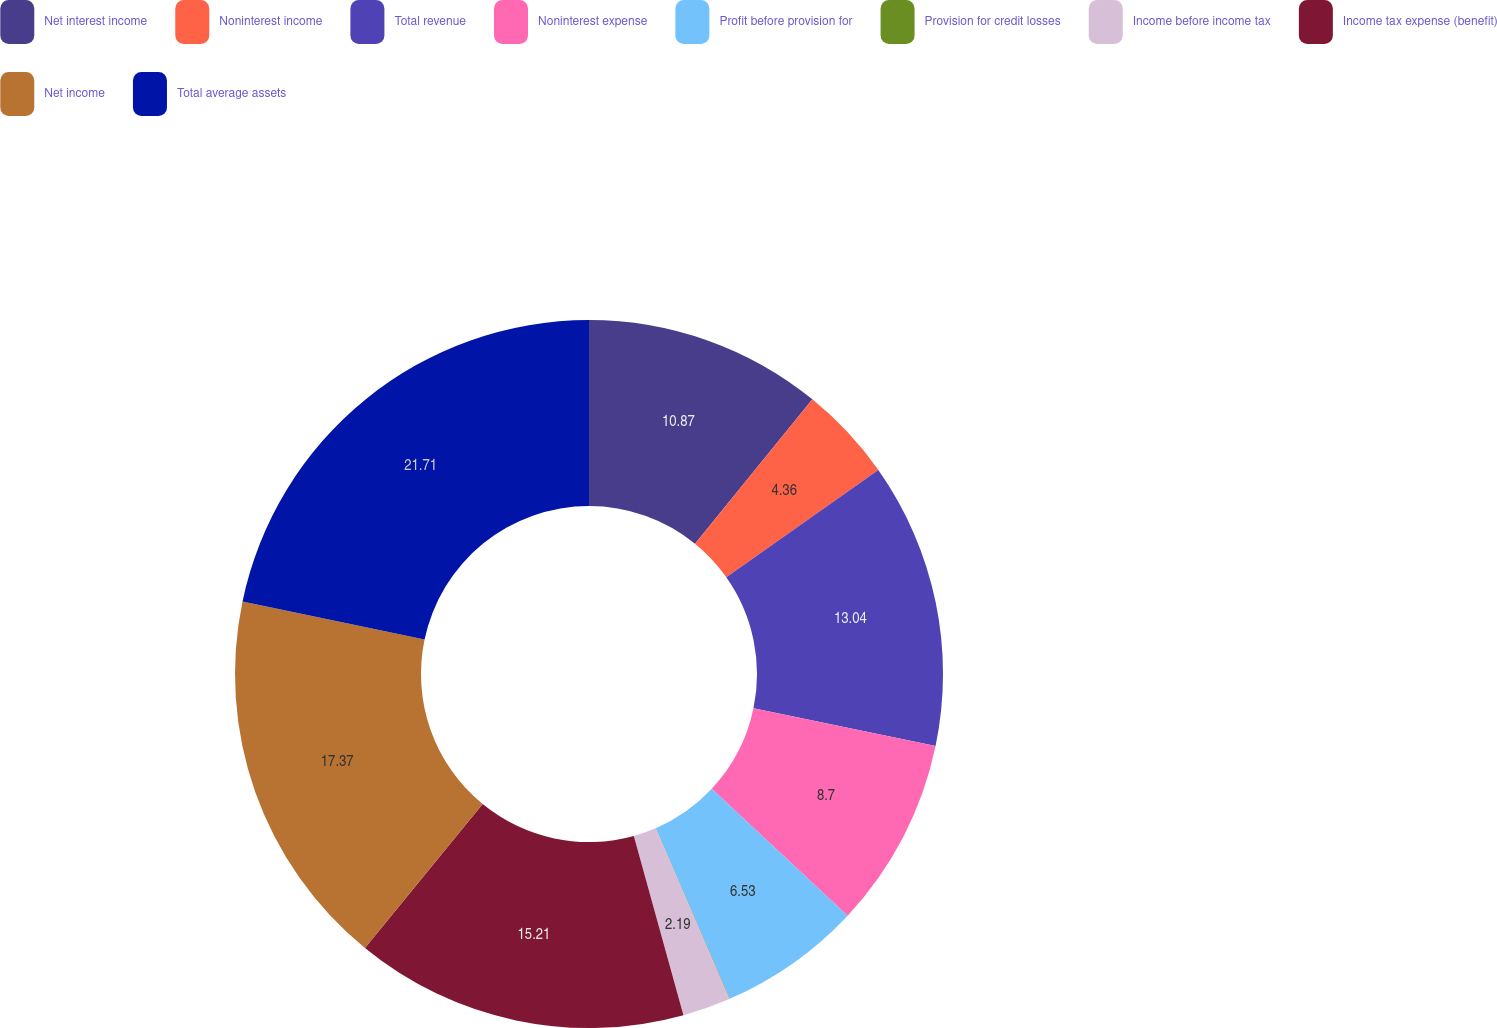<chart> <loc_0><loc_0><loc_500><loc_500><pie_chart><fcel>Net interest income<fcel>Noninterest income<fcel>Total revenue<fcel>Noninterest expense<fcel>Profit before provision for<fcel>Provision for credit losses<fcel>Income before income tax<fcel>Income tax expense (benefit)<fcel>Net income<fcel>Total average assets<nl><fcel>10.87%<fcel>4.36%<fcel>13.04%<fcel>8.7%<fcel>6.53%<fcel>0.02%<fcel>2.19%<fcel>15.21%<fcel>17.38%<fcel>21.72%<nl></chart> 